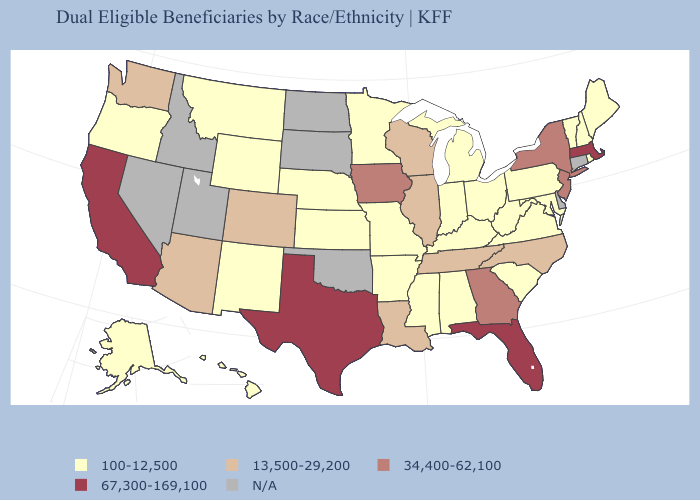Does Florida have the highest value in the USA?
Give a very brief answer. Yes. Which states hav the highest value in the South?
Give a very brief answer. Florida, Texas. Which states have the highest value in the USA?
Quick response, please. California, Florida, Massachusetts, Texas. Is the legend a continuous bar?
Concise answer only. No. Among the states that border Georgia , which have the lowest value?
Give a very brief answer. Alabama, South Carolina. Name the states that have a value in the range 67,300-169,100?
Short answer required. California, Florida, Massachusetts, Texas. What is the lowest value in the USA?
Concise answer only. 100-12,500. What is the highest value in the MidWest ?
Answer briefly. 34,400-62,100. What is the highest value in states that border Indiana?
Quick response, please. 13,500-29,200. What is the value of California?
Give a very brief answer. 67,300-169,100. What is the value of Oklahoma?
Short answer required. N/A. Name the states that have a value in the range 100-12,500?
Short answer required. Alabama, Alaska, Arkansas, Hawaii, Indiana, Kansas, Kentucky, Maine, Maryland, Michigan, Minnesota, Mississippi, Missouri, Montana, Nebraska, New Hampshire, New Mexico, Ohio, Oregon, Pennsylvania, Rhode Island, South Carolina, Vermont, Virginia, West Virginia, Wyoming. How many symbols are there in the legend?
Write a very short answer. 5. Name the states that have a value in the range 13,500-29,200?
Keep it brief. Arizona, Colorado, Illinois, Louisiana, North Carolina, Tennessee, Washington, Wisconsin. 